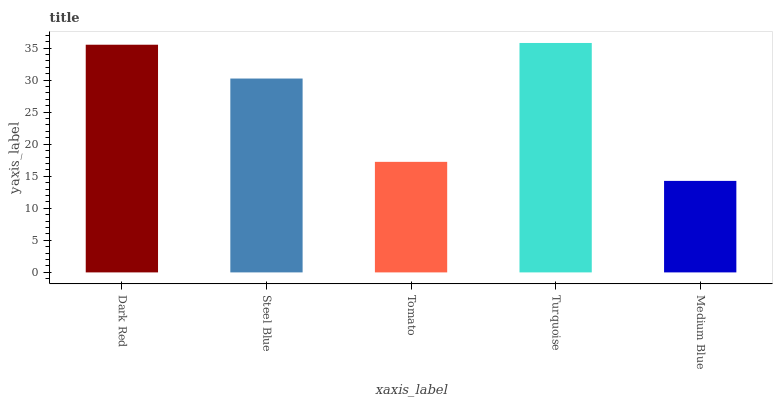Is Steel Blue the minimum?
Answer yes or no. No. Is Steel Blue the maximum?
Answer yes or no. No. Is Dark Red greater than Steel Blue?
Answer yes or no. Yes. Is Steel Blue less than Dark Red?
Answer yes or no. Yes. Is Steel Blue greater than Dark Red?
Answer yes or no. No. Is Dark Red less than Steel Blue?
Answer yes or no. No. Is Steel Blue the high median?
Answer yes or no. Yes. Is Steel Blue the low median?
Answer yes or no. Yes. Is Turquoise the high median?
Answer yes or no. No. Is Turquoise the low median?
Answer yes or no. No. 